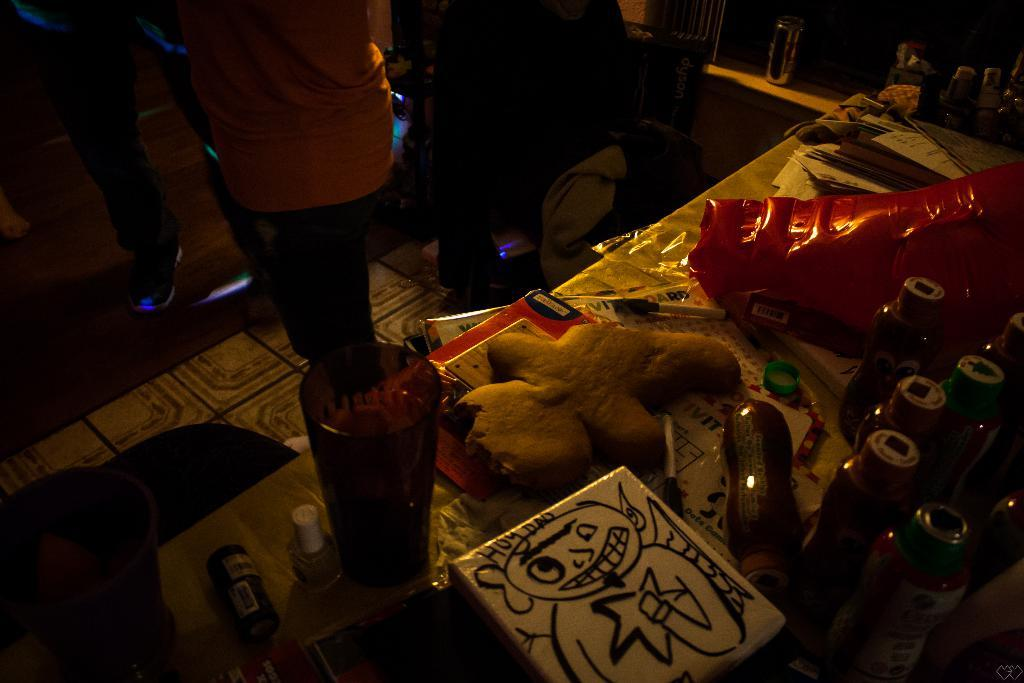What are the persons in the image doing? The persons in the image are standing on the floor. What is placed beside the persons? A table is placed beside the persons. What items can be seen on the table? There are nail polishes, tumblers, plastic bottles, a pen, toys, and books on the table. Can you see any icicles forming on the table in the image? There are no icicles present in the image; it is not cold enough for them to form. What type of thunder can be heard in the background of the image? There is no thunder present in the image, as it is a still image and does not contain any sound. 